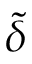<formula> <loc_0><loc_0><loc_500><loc_500>\tilde { \delta }</formula> 